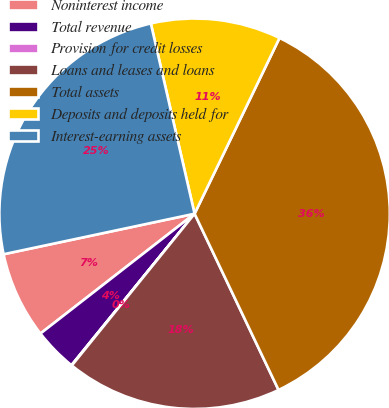Convert chart. <chart><loc_0><loc_0><loc_500><loc_500><pie_chart><fcel>Noninterest income<fcel>Total revenue<fcel>Provision for credit losses<fcel>Loans and leases and loans<fcel>Total assets<fcel>Deposits and deposits held for<fcel>Interest-earning assets<nl><fcel>7.19%<fcel>3.62%<fcel>0.04%<fcel>17.9%<fcel>35.76%<fcel>10.76%<fcel>24.73%<nl></chart> 